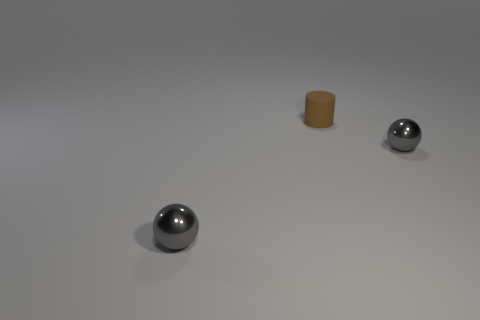Add 2 brown rubber cylinders. How many objects exist? 5 Subtract all balls. How many objects are left? 1 Subtract 0 cyan cylinders. How many objects are left? 3 Subtract 2 spheres. How many spheres are left? 0 Subtract all red cylinders. Subtract all blue blocks. How many cylinders are left? 1 Subtract all small things. Subtract all green matte balls. How many objects are left? 0 Add 2 gray shiny things. How many gray shiny things are left? 4 Add 1 gray spheres. How many gray spheres exist? 3 